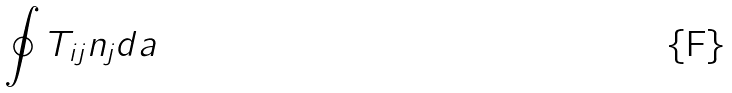Convert formula to latex. <formula><loc_0><loc_0><loc_500><loc_500>\oint T _ { i j } n _ { j } d a</formula> 